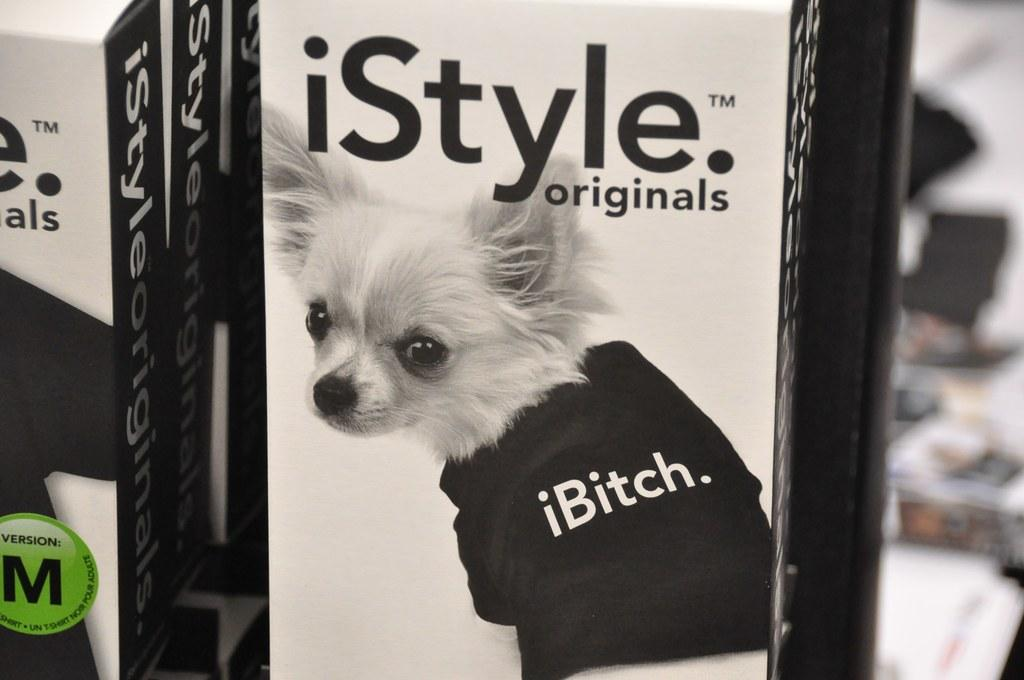What type of animal is in the image? There is a dog in the image. What is the dog wearing? The dog is wearing a black dress. What can be seen besides the dog in the image? There are white and black color boxes in the image. What is written on the boxes? There is writing on the boxes. How would you describe the background of the image? The background of the image is blurred. What country is the dog visiting in the image? There is no indication of the dog visiting a country in the image. Can you see the moon in the image? The moon is not visible in the image. 